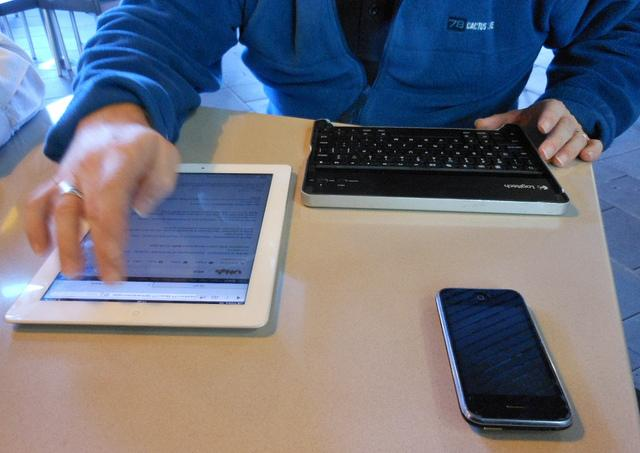Why is he touching the screen? Please explain your reasoning. navigating. There are multiple tabs open on the tablet. he is switching between them. 